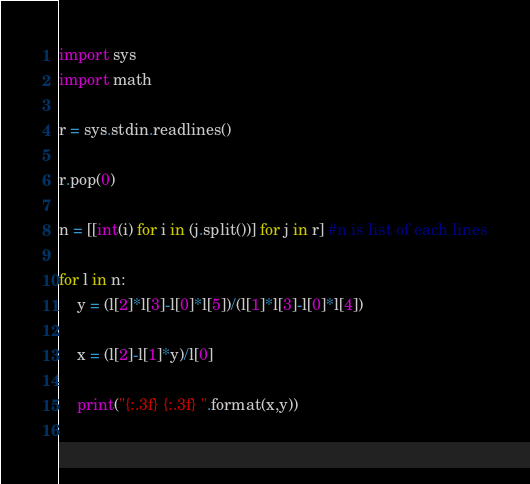<code> <loc_0><loc_0><loc_500><loc_500><_Python_>import sys
import math

r = sys.stdin.readlines()

r.pop(0)

n = [[int(i) for i in (j.split())] for j in r] #n is list of each lines

for l in n:
    y = (l[2]*l[3]-l[0]*l[5])/(l[1]*l[3]-l[0]*l[4])
    
    x = (l[2]-l[1]*y)/l[0]
    
    print("{:.3f} {:.3f} ".format(x,y))
    </code> 